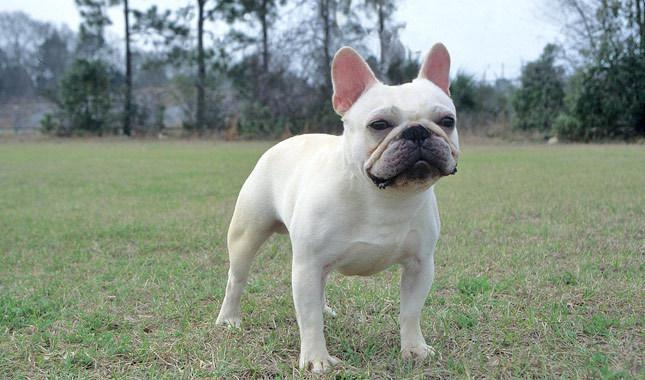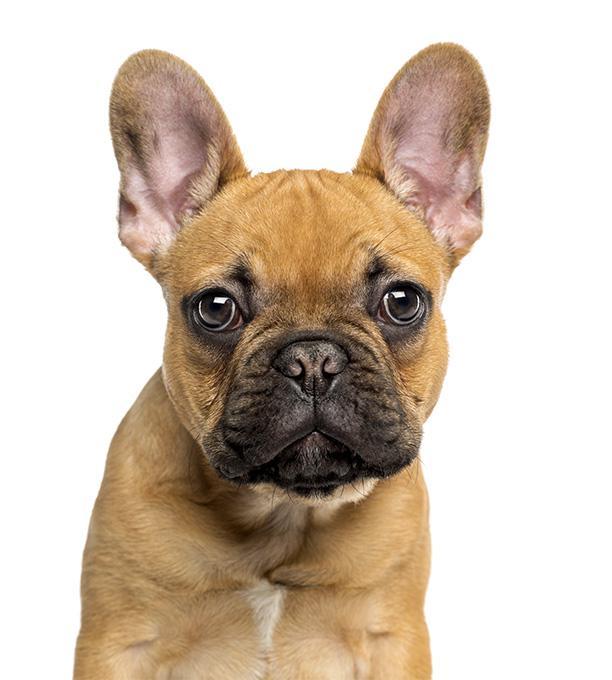The first image is the image on the left, the second image is the image on the right. Examine the images to the left and right. Is the description "One of the images does not show the entire body of the dog." accurate? Answer yes or no. Yes. 